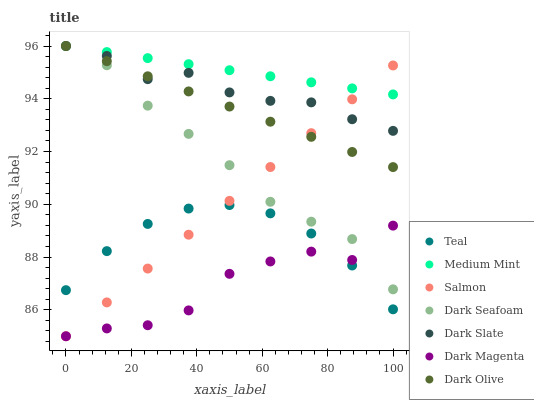Does Dark Magenta have the minimum area under the curve?
Answer yes or no. Yes. Does Medium Mint have the maximum area under the curve?
Answer yes or no. Yes. Does Dark Olive have the minimum area under the curve?
Answer yes or no. No. Does Dark Olive have the maximum area under the curve?
Answer yes or no. No. Is Salmon the smoothest?
Answer yes or no. Yes. Is Dark Magenta the roughest?
Answer yes or no. Yes. Is Dark Olive the smoothest?
Answer yes or no. No. Is Dark Olive the roughest?
Answer yes or no. No. Does Dark Magenta have the lowest value?
Answer yes or no. Yes. Does Dark Olive have the lowest value?
Answer yes or no. No. Does Dark Seafoam have the highest value?
Answer yes or no. Yes. Does Dark Magenta have the highest value?
Answer yes or no. No. Is Dark Magenta less than Dark Slate?
Answer yes or no. Yes. Is Dark Slate greater than Teal?
Answer yes or no. Yes. Does Dark Olive intersect Salmon?
Answer yes or no. Yes. Is Dark Olive less than Salmon?
Answer yes or no. No. Is Dark Olive greater than Salmon?
Answer yes or no. No. Does Dark Magenta intersect Dark Slate?
Answer yes or no. No. 